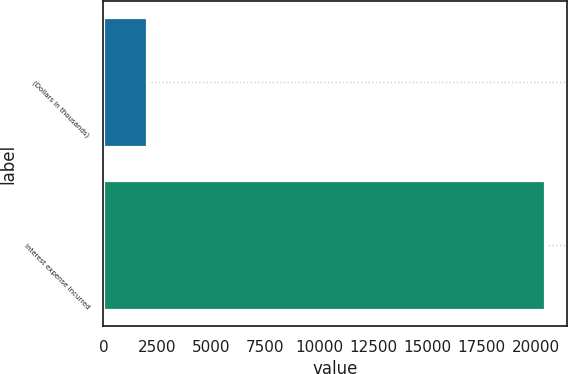Convert chart. <chart><loc_0><loc_0><loc_500><loc_500><bar_chart><fcel>(Dollars in thousands)<fcel>Interest expense incurred<nl><fcel>2011<fcel>20454<nl></chart> 